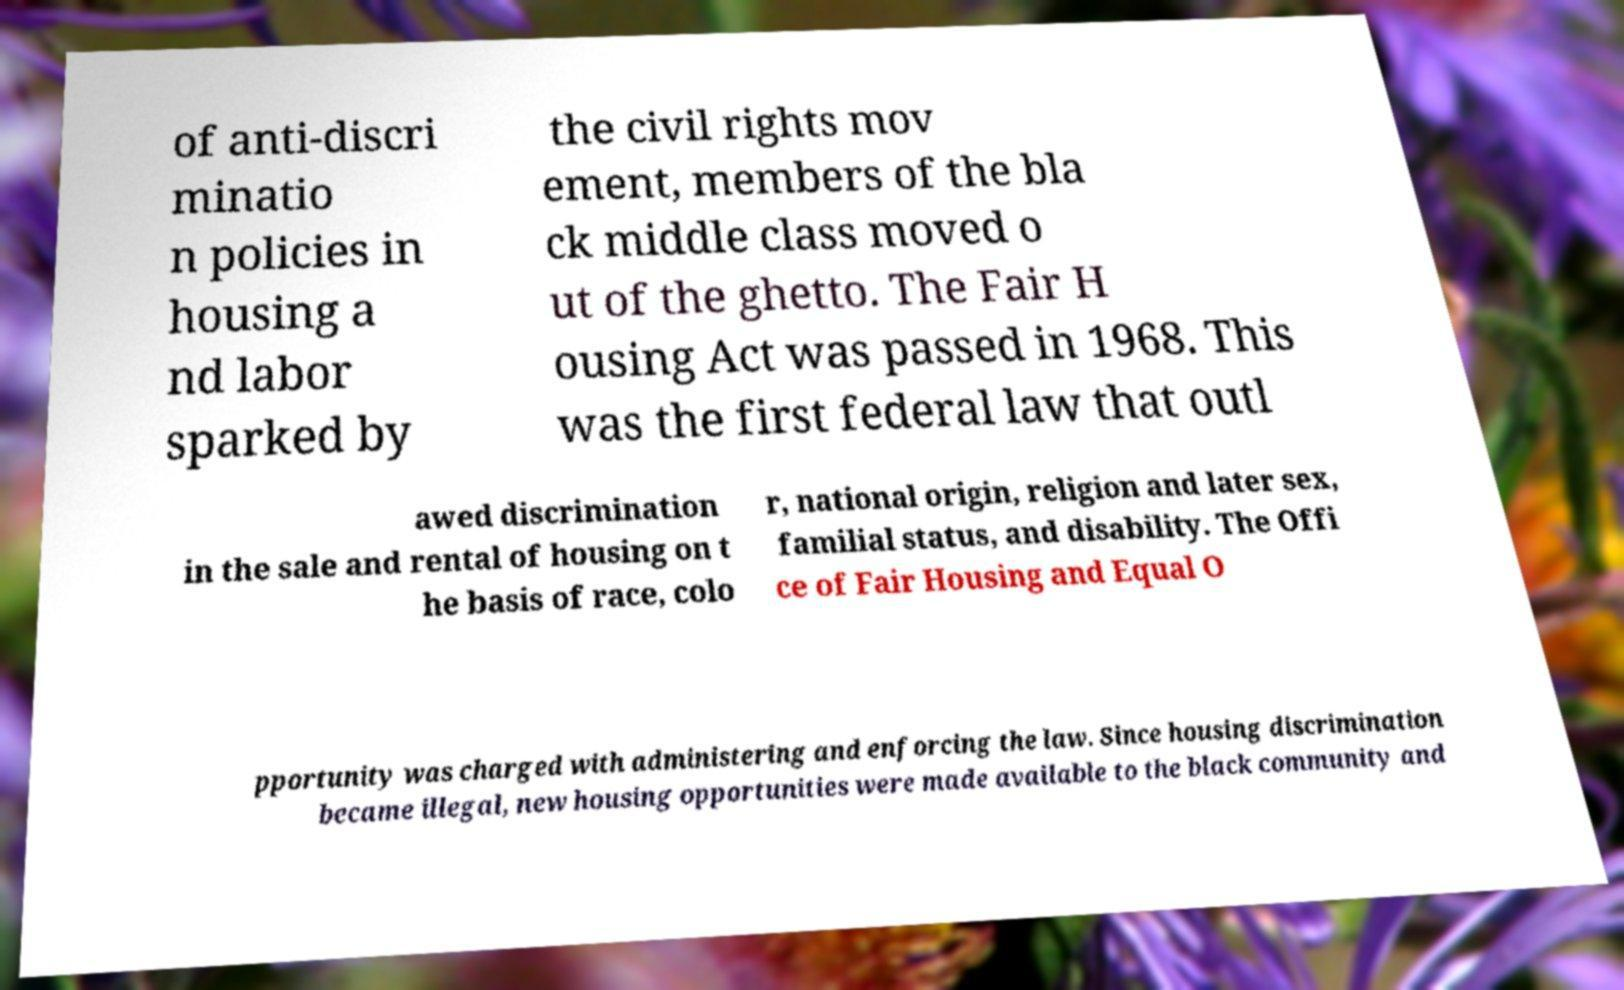Could you assist in decoding the text presented in this image and type it out clearly? of anti-discri minatio n policies in housing a nd labor sparked by the civil rights mov ement, members of the bla ck middle class moved o ut of the ghetto. The Fair H ousing Act was passed in 1968. This was the first federal law that outl awed discrimination in the sale and rental of housing on t he basis of race, colo r, national origin, religion and later sex, familial status, and disability. The Offi ce of Fair Housing and Equal O pportunity was charged with administering and enforcing the law. Since housing discrimination became illegal, new housing opportunities were made available to the black community and 